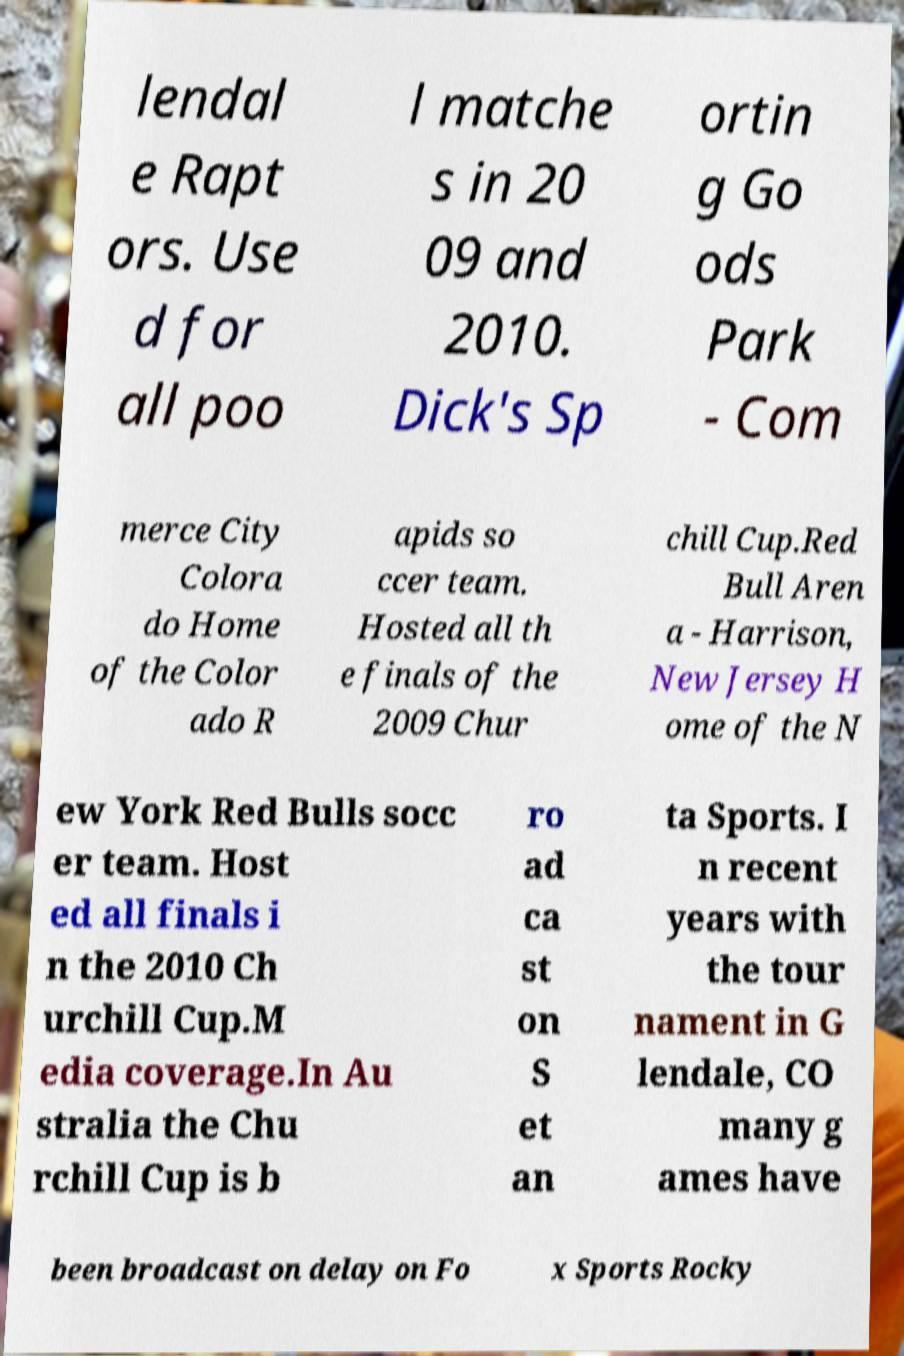Could you extract and type out the text from this image? lendal e Rapt ors. Use d for all poo l matche s in 20 09 and 2010. Dick's Sp ortin g Go ods Park - Com merce City Colora do Home of the Color ado R apids so ccer team. Hosted all th e finals of the 2009 Chur chill Cup.Red Bull Aren a - Harrison, New Jersey H ome of the N ew York Red Bulls socc er team. Host ed all finals i n the 2010 Ch urchill Cup.M edia coverage.In Au stralia the Chu rchill Cup is b ro ad ca st on S et an ta Sports. I n recent years with the tour nament in G lendale, CO many g ames have been broadcast on delay on Fo x Sports Rocky 